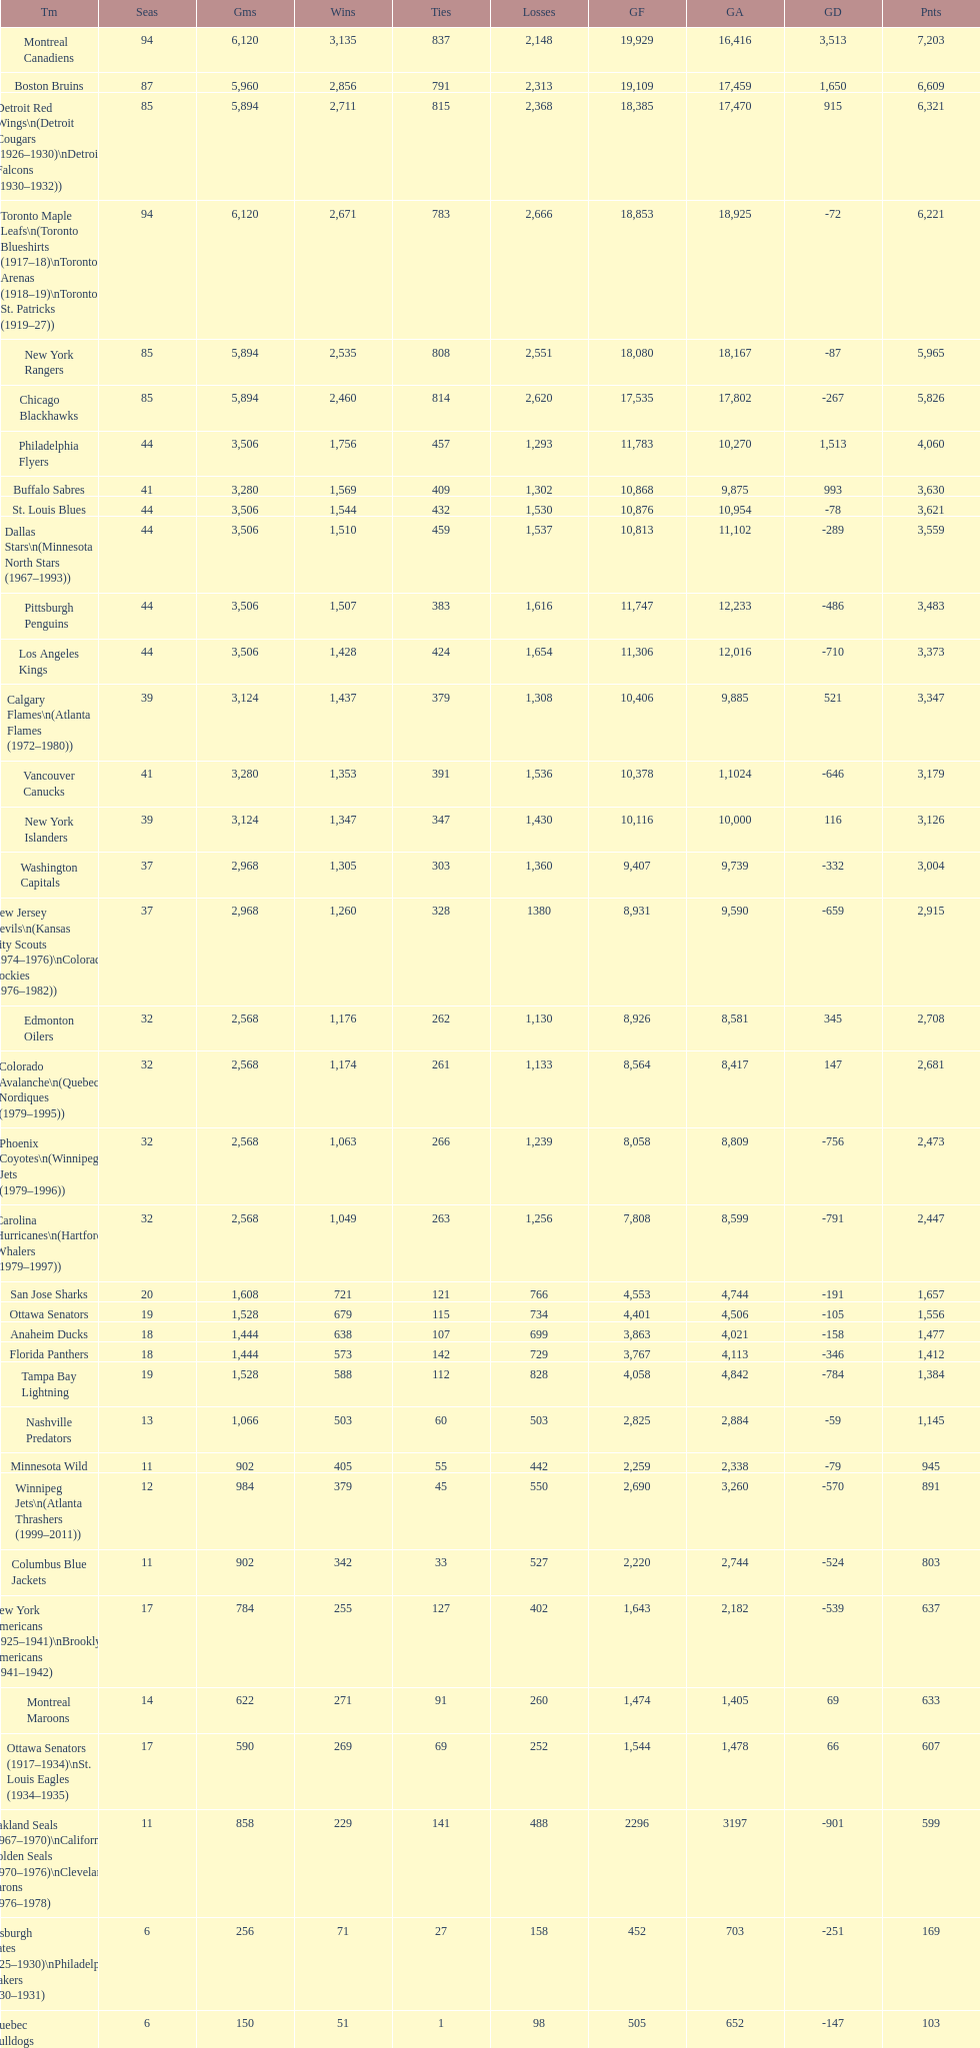How many teams have won more than 1,500 games? 11. 